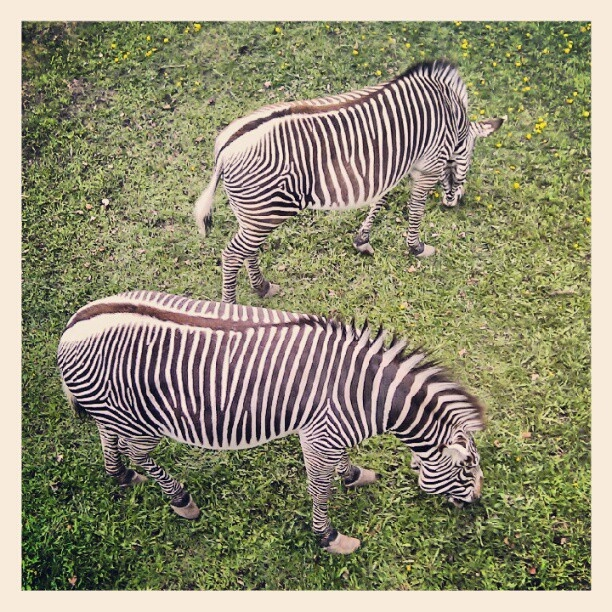Describe the objects in this image and their specific colors. I can see zebra in ivory, lightgray, gray, black, and darkgray tones and zebra in ivory, lightgray, gray, darkgray, and black tones in this image. 